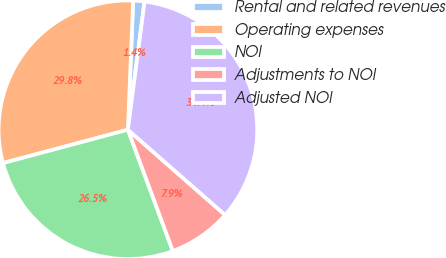<chart> <loc_0><loc_0><loc_500><loc_500><pie_chart><fcel>Rental and related revenues<fcel>Operating expenses<fcel>NOI<fcel>Adjustments to NOI<fcel>Adjusted NOI<nl><fcel>1.41%<fcel>29.8%<fcel>26.5%<fcel>7.9%<fcel>34.4%<nl></chart> 